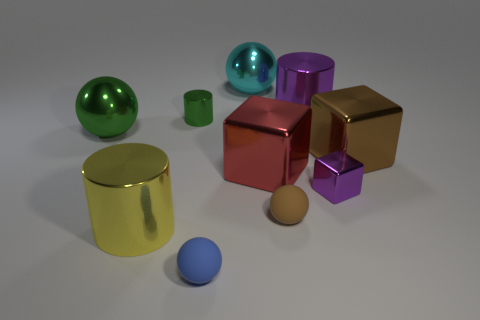Subtract all big green metallic spheres. How many spheres are left? 3 Subtract 1 cubes. How many cubes are left? 2 Subtract all brown balls. How many balls are left? 3 Subtract all cubes. How many objects are left? 7 Subtract all big things. Subtract all blue rubber things. How many objects are left? 3 Add 3 large metallic balls. How many large metallic balls are left? 5 Add 6 metallic cylinders. How many metallic cylinders exist? 9 Subtract 1 red cubes. How many objects are left? 9 Subtract all red blocks. Subtract all yellow cylinders. How many blocks are left? 2 